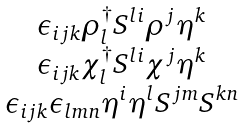<formula> <loc_0><loc_0><loc_500><loc_500>\begin{array} { c } \epsilon _ { i j k } \rho _ { l } ^ { \dagger } S ^ { l i } \rho ^ { j } \eta ^ { k } \\ \epsilon _ { i j k } \chi _ { l } ^ { \dagger } S ^ { l i } \chi ^ { j } \eta ^ { k } \\ \epsilon _ { i j k } \epsilon _ { l m n } \eta ^ { i } \eta ^ { l } S ^ { j m } S ^ { k n } \end{array}</formula> 